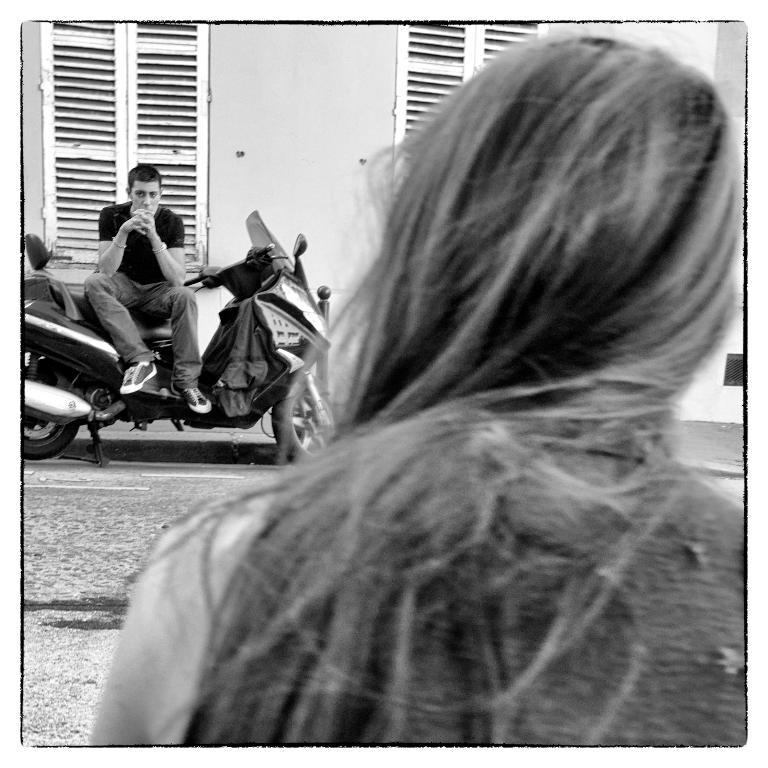What is the color scheme of the image? The image is black and white. Who is the main subject in the middle of the image? There is a girl with long hair in the middle of the image. What is the man in the image doing? The man is sitting on a bike in front of the girl. What can be seen beside the man on the bike? There are windows beside the man on the bike. What type of toothbrush is the girl using in the image? There is no toothbrush present in the image. Has the girl received a letter from a friend in the image? There is no mention of a letter or any communication in the image. 